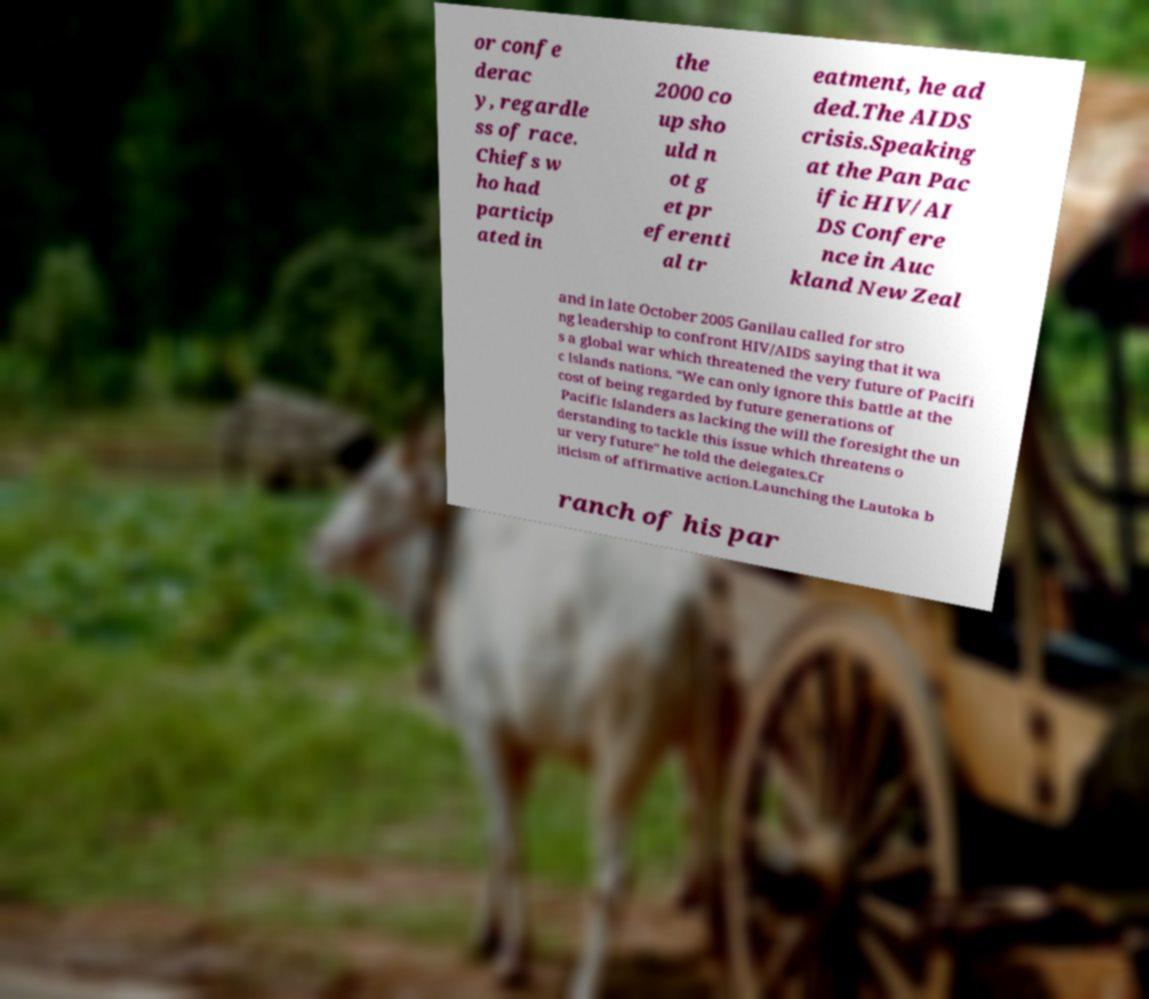There's text embedded in this image that I need extracted. Can you transcribe it verbatim? or confe derac y, regardle ss of race. Chiefs w ho had particip ated in the 2000 co up sho uld n ot g et pr eferenti al tr eatment, he ad ded.The AIDS crisis.Speaking at the Pan Pac ific HIV/AI DS Confere nce in Auc kland New Zeal and in late October 2005 Ganilau called for stro ng leadership to confront HIV/AIDS saying that it wa s a global war which threatened the very future of Pacifi c Islands nations. "We can only ignore this battle at the cost of being regarded by future generations of Pacific Islanders as lacking the will the foresight the un derstanding to tackle this issue which threatens o ur very future" he told the delegates.Cr iticism of affirmative action.Launching the Lautoka b ranch of his par 